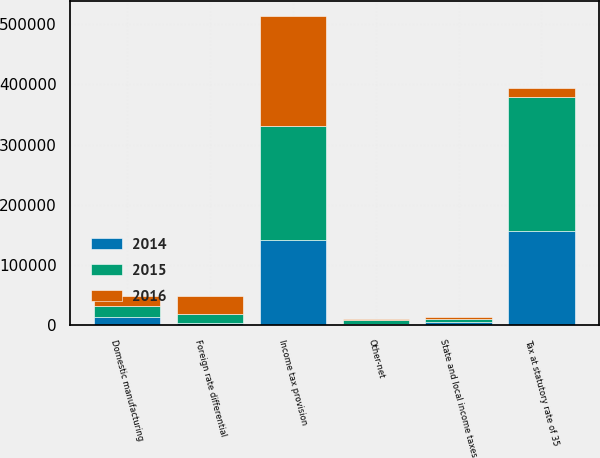<chart> <loc_0><loc_0><loc_500><loc_500><stacked_bar_chart><ecel><fcel>Tax at statutory rate of 35<fcel>State and local income taxes<fcel>Foreign rate differential<fcel>Domestic manufacturing<fcel>Other-net<fcel>Income tax provision<nl><fcel>2016<fcel>14332<fcel>2677<fcel>30079<fcel>16902<fcel>730<fcel>181702<nl><fcel>2015<fcel>222888<fcel>4931<fcel>14332<fcel>17834<fcel>6041<fcel>189612<nl><fcel>2014<fcel>156979<fcel>5658<fcel>4034<fcel>13980<fcel>3023<fcel>141600<nl></chart> 